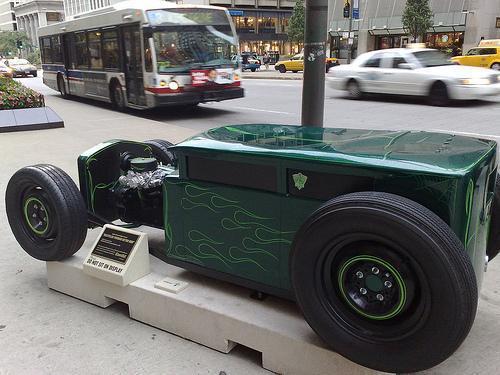How many buses are there?
Give a very brief answer. 1. 